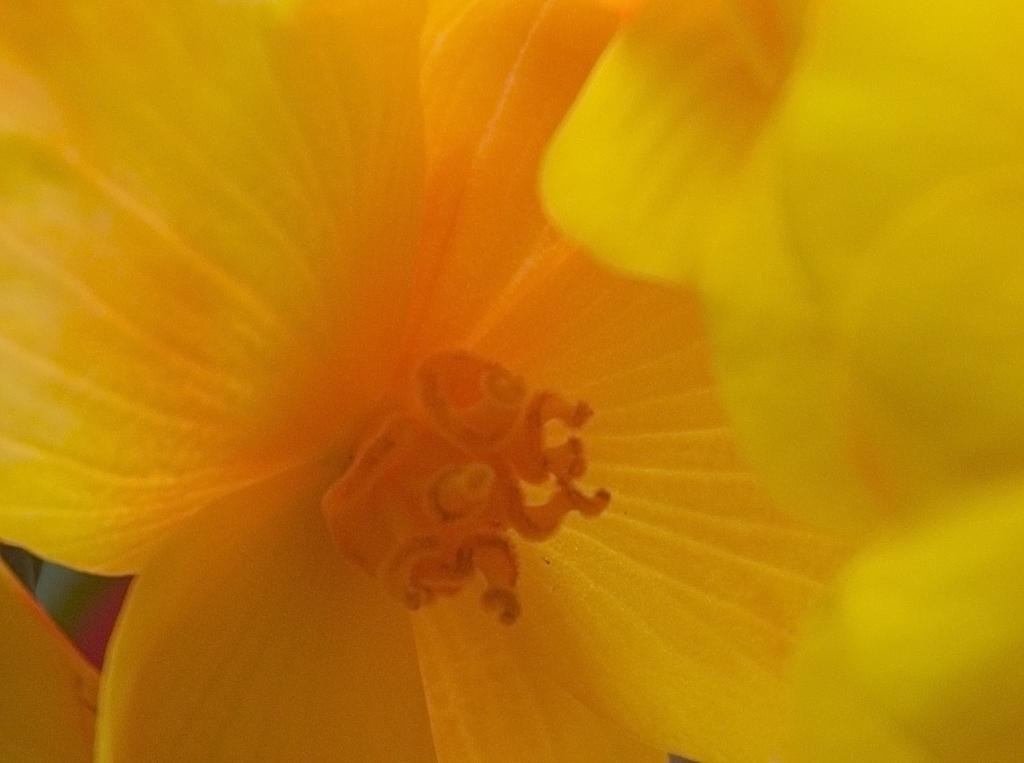What type of plants can be seen in the image? There are flowers in the image. What color are the petals of the flowers? The flowers have yellow petals. What can be found in the center of the flowers? There are pollen grains in the center of the flowers. How far away are the frogs from the flowers in the image? There are no frogs present in the image, so it is not possible to determine their distance from the flowers. 